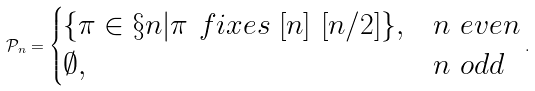Convert formula to latex. <formula><loc_0><loc_0><loc_500><loc_500>\mathcal { P } _ { n } = \begin{cases} \{ \pi \in \S { n } | \pi \ f i x e s \ [ n ] \ [ n / 2 ] \} , & n \ e v e n \\ \emptyset , & n \ o d d \end{cases} .</formula> 